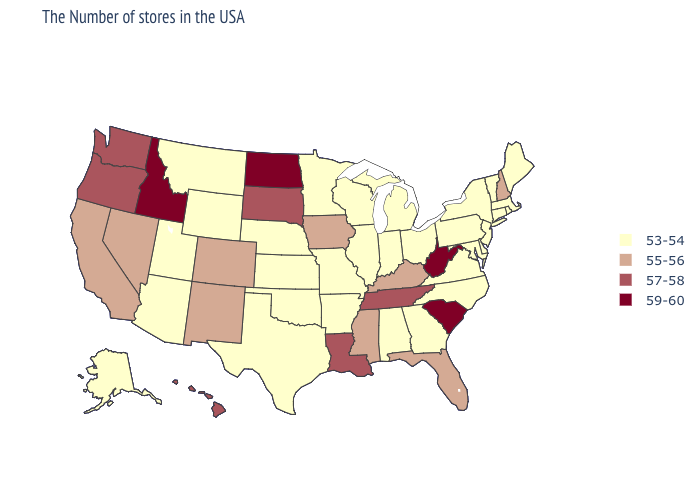Among the states that border West Virginia , does Kentucky have the lowest value?
Answer briefly. No. Among the states that border Indiana , which have the highest value?
Write a very short answer. Kentucky. Name the states that have a value in the range 59-60?
Answer briefly. South Carolina, West Virginia, North Dakota, Idaho. What is the value of Hawaii?
Give a very brief answer. 57-58. Name the states that have a value in the range 57-58?
Concise answer only. Tennessee, Louisiana, South Dakota, Washington, Oregon, Hawaii. What is the value of Rhode Island?
Concise answer only. 53-54. What is the value of New York?
Quick response, please. 53-54. Does New Hampshire have the highest value in the Northeast?
Concise answer only. Yes. Which states have the lowest value in the USA?
Quick response, please. Maine, Massachusetts, Rhode Island, Vermont, Connecticut, New York, New Jersey, Delaware, Maryland, Pennsylvania, Virginia, North Carolina, Ohio, Georgia, Michigan, Indiana, Alabama, Wisconsin, Illinois, Missouri, Arkansas, Minnesota, Kansas, Nebraska, Oklahoma, Texas, Wyoming, Utah, Montana, Arizona, Alaska. Name the states that have a value in the range 57-58?
Short answer required. Tennessee, Louisiana, South Dakota, Washington, Oregon, Hawaii. Is the legend a continuous bar?
Write a very short answer. No. What is the highest value in the USA?
Short answer required. 59-60. Name the states that have a value in the range 55-56?
Be succinct. New Hampshire, Florida, Kentucky, Mississippi, Iowa, Colorado, New Mexico, Nevada, California. Does New Mexico have the lowest value in the USA?
Keep it brief. No. Does West Virginia have the highest value in the South?
Keep it brief. Yes. 